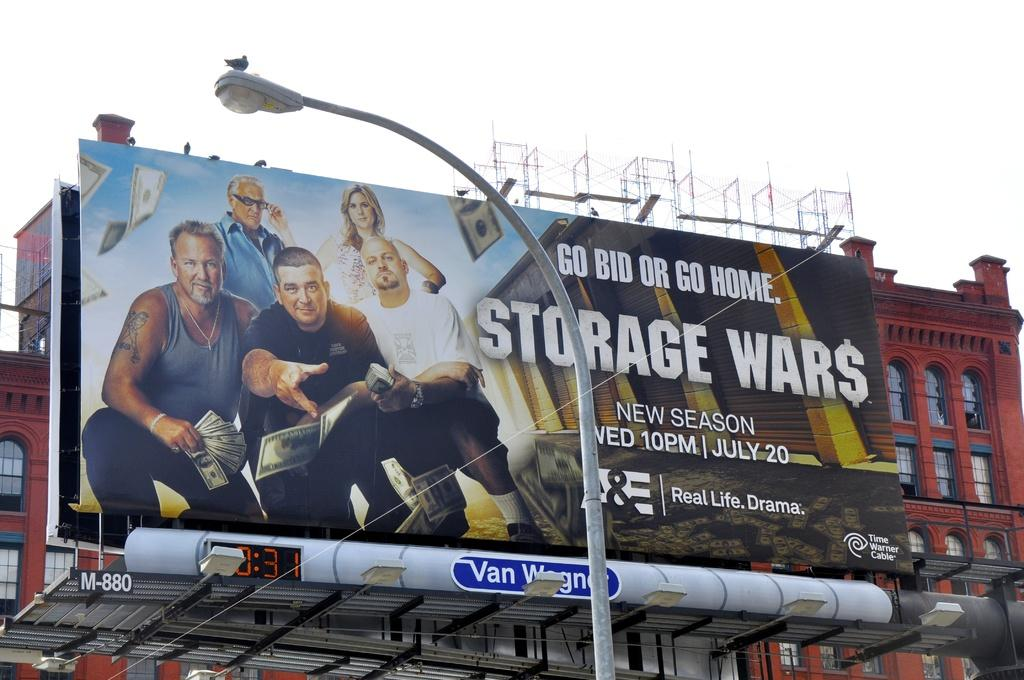Provide a one-sentence caption for the provided image. A large billboard advertises the show Storage Wars. 